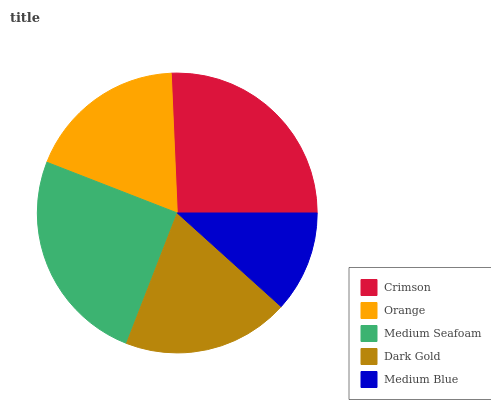Is Medium Blue the minimum?
Answer yes or no. Yes. Is Crimson the maximum?
Answer yes or no. Yes. Is Orange the minimum?
Answer yes or no. No. Is Orange the maximum?
Answer yes or no. No. Is Crimson greater than Orange?
Answer yes or no. Yes. Is Orange less than Crimson?
Answer yes or no. Yes. Is Orange greater than Crimson?
Answer yes or no. No. Is Crimson less than Orange?
Answer yes or no. No. Is Dark Gold the high median?
Answer yes or no. Yes. Is Dark Gold the low median?
Answer yes or no. Yes. Is Medium Blue the high median?
Answer yes or no. No. Is Orange the low median?
Answer yes or no. No. 